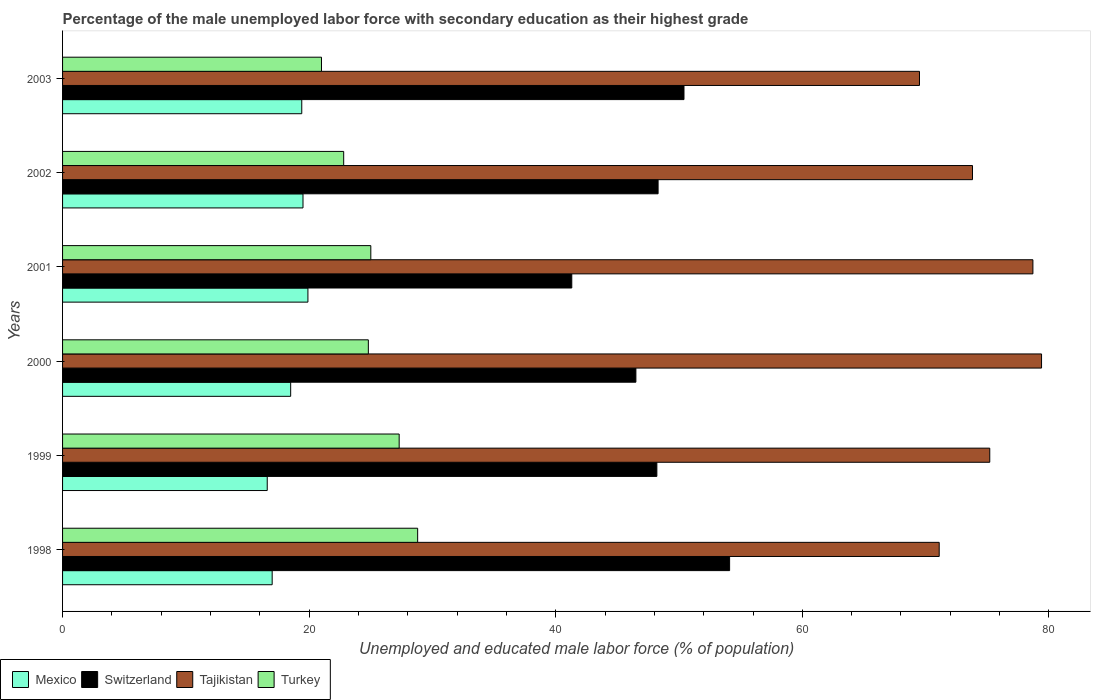How many different coloured bars are there?
Give a very brief answer. 4. How many groups of bars are there?
Your response must be concise. 6. Are the number of bars per tick equal to the number of legend labels?
Your answer should be compact. Yes. How many bars are there on the 2nd tick from the top?
Ensure brevity in your answer.  4. In how many cases, is the number of bars for a given year not equal to the number of legend labels?
Provide a short and direct response. 0. What is the percentage of the unemployed male labor force with secondary education in Turkey in 2002?
Ensure brevity in your answer.  22.8. Across all years, what is the maximum percentage of the unemployed male labor force with secondary education in Turkey?
Your answer should be compact. 28.8. In which year was the percentage of the unemployed male labor force with secondary education in Switzerland maximum?
Offer a terse response. 1998. In which year was the percentage of the unemployed male labor force with secondary education in Tajikistan minimum?
Give a very brief answer. 2003. What is the total percentage of the unemployed male labor force with secondary education in Switzerland in the graph?
Provide a succinct answer. 288.8. What is the difference between the percentage of the unemployed male labor force with secondary education in Mexico in 2001 and that in 2002?
Give a very brief answer. 0.4. What is the difference between the percentage of the unemployed male labor force with secondary education in Tajikistan in 2001 and the percentage of the unemployed male labor force with secondary education in Turkey in 2002?
Your answer should be compact. 55.9. What is the average percentage of the unemployed male labor force with secondary education in Switzerland per year?
Your answer should be compact. 48.13. In the year 2002, what is the difference between the percentage of the unemployed male labor force with secondary education in Turkey and percentage of the unemployed male labor force with secondary education in Tajikistan?
Provide a succinct answer. -51. What is the ratio of the percentage of the unemployed male labor force with secondary education in Switzerland in 1999 to that in 2001?
Keep it short and to the point. 1.17. Is the percentage of the unemployed male labor force with secondary education in Mexico in 1998 less than that in 2003?
Your answer should be very brief. Yes. Is the difference between the percentage of the unemployed male labor force with secondary education in Turkey in 1999 and 2003 greater than the difference between the percentage of the unemployed male labor force with secondary education in Tajikistan in 1999 and 2003?
Your answer should be compact. Yes. What is the difference between the highest and the second highest percentage of the unemployed male labor force with secondary education in Switzerland?
Your answer should be very brief. 3.7. What is the difference between the highest and the lowest percentage of the unemployed male labor force with secondary education in Switzerland?
Offer a terse response. 12.8. What does the 2nd bar from the top in 2003 represents?
Offer a very short reply. Tajikistan. Are the values on the major ticks of X-axis written in scientific E-notation?
Make the answer very short. No. How many legend labels are there?
Your answer should be very brief. 4. What is the title of the graph?
Ensure brevity in your answer.  Percentage of the male unemployed labor force with secondary education as their highest grade. What is the label or title of the X-axis?
Keep it short and to the point. Unemployed and educated male labor force (% of population). What is the label or title of the Y-axis?
Keep it short and to the point. Years. What is the Unemployed and educated male labor force (% of population) in Mexico in 1998?
Provide a succinct answer. 17. What is the Unemployed and educated male labor force (% of population) of Switzerland in 1998?
Give a very brief answer. 54.1. What is the Unemployed and educated male labor force (% of population) of Tajikistan in 1998?
Offer a very short reply. 71.1. What is the Unemployed and educated male labor force (% of population) in Turkey in 1998?
Your answer should be very brief. 28.8. What is the Unemployed and educated male labor force (% of population) of Mexico in 1999?
Give a very brief answer. 16.6. What is the Unemployed and educated male labor force (% of population) in Switzerland in 1999?
Offer a terse response. 48.2. What is the Unemployed and educated male labor force (% of population) in Tajikistan in 1999?
Offer a very short reply. 75.2. What is the Unemployed and educated male labor force (% of population) of Turkey in 1999?
Offer a terse response. 27.3. What is the Unemployed and educated male labor force (% of population) of Mexico in 2000?
Offer a terse response. 18.5. What is the Unemployed and educated male labor force (% of population) of Switzerland in 2000?
Provide a short and direct response. 46.5. What is the Unemployed and educated male labor force (% of population) in Tajikistan in 2000?
Offer a very short reply. 79.4. What is the Unemployed and educated male labor force (% of population) of Turkey in 2000?
Offer a very short reply. 24.8. What is the Unemployed and educated male labor force (% of population) of Mexico in 2001?
Provide a short and direct response. 19.9. What is the Unemployed and educated male labor force (% of population) in Switzerland in 2001?
Your answer should be compact. 41.3. What is the Unemployed and educated male labor force (% of population) in Tajikistan in 2001?
Your answer should be very brief. 78.7. What is the Unemployed and educated male labor force (% of population) in Turkey in 2001?
Ensure brevity in your answer.  25. What is the Unemployed and educated male labor force (% of population) in Switzerland in 2002?
Your answer should be compact. 48.3. What is the Unemployed and educated male labor force (% of population) of Tajikistan in 2002?
Your answer should be compact. 73.8. What is the Unemployed and educated male labor force (% of population) in Turkey in 2002?
Make the answer very short. 22.8. What is the Unemployed and educated male labor force (% of population) in Mexico in 2003?
Provide a short and direct response. 19.4. What is the Unemployed and educated male labor force (% of population) of Switzerland in 2003?
Your answer should be very brief. 50.4. What is the Unemployed and educated male labor force (% of population) in Tajikistan in 2003?
Your response must be concise. 69.5. What is the Unemployed and educated male labor force (% of population) of Turkey in 2003?
Provide a short and direct response. 21. Across all years, what is the maximum Unemployed and educated male labor force (% of population) in Mexico?
Give a very brief answer. 19.9. Across all years, what is the maximum Unemployed and educated male labor force (% of population) of Switzerland?
Your answer should be very brief. 54.1. Across all years, what is the maximum Unemployed and educated male labor force (% of population) in Tajikistan?
Provide a short and direct response. 79.4. Across all years, what is the maximum Unemployed and educated male labor force (% of population) of Turkey?
Offer a terse response. 28.8. Across all years, what is the minimum Unemployed and educated male labor force (% of population) of Mexico?
Give a very brief answer. 16.6. Across all years, what is the minimum Unemployed and educated male labor force (% of population) of Switzerland?
Provide a succinct answer. 41.3. Across all years, what is the minimum Unemployed and educated male labor force (% of population) of Tajikistan?
Give a very brief answer. 69.5. Across all years, what is the minimum Unemployed and educated male labor force (% of population) in Turkey?
Your answer should be compact. 21. What is the total Unemployed and educated male labor force (% of population) in Mexico in the graph?
Offer a terse response. 110.9. What is the total Unemployed and educated male labor force (% of population) in Switzerland in the graph?
Your answer should be compact. 288.8. What is the total Unemployed and educated male labor force (% of population) in Tajikistan in the graph?
Provide a short and direct response. 447.7. What is the total Unemployed and educated male labor force (% of population) in Turkey in the graph?
Provide a short and direct response. 149.7. What is the difference between the Unemployed and educated male labor force (% of population) in Turkey in 1998 and that in 1999?
Provide a short and direct response. 1.5. What is the difference between the Unemployed and educated male labor force (% of population) in Mexico in 1998 and that in 2000?
Provide a short and direct response. -1.5. What is the difference between the Unemployed and educated male labor force (% of population) of Switzerland in 1998 and that in 2000?
Provide a succinct answer. 7.6. What is the difference between the Unemployed and educated male labor force (% of population) in Turkey in 1998 and that in 2000?
Provide a short and direct response. 4. What is the difference between the Unemployed and educated male labor force (% of population) in Tajikistan in 1998 and that in 2001?
Keep it short and to the point. -7.6. What is the difference between the Unemployed and educated male labor force (% of population) in Turkey in 1998 and that in 2001?
Offer a terse response. 3.8. What is the difference between the Unemployed and educated male labor force (% of population) of Mexico in 1998 and that in 2002?
Provide a succinct answer. -2.5. What is the difference between the Unemployed and educated male labor force (% of population) of Switzerland in 1998 and that in 2002?
Your answer should be compact. 5.8. What is the difference between the Unemployed and educated male labor force (% of population) of Tajikistan in 1998 and that in 2002?
Keep it short and to the point. -2.7. What is the difference between the Unemployed and educated male labor force (% of population) of Turkey in 1998 and that in 2003?
Give a very brief answer. 7.8. What is the difference between the Unemployed and educated male labor force (% of population) of Mexico in 1999 and that in 2000?
Offer a terse response. -1.9. What is the difference between the Unemployed and educated male labor force (% of population) of Tajikistan in 1999 and that in 2000?
Keep it short and to the point. -4.2. What is the difference between the Unemployed and educated male labor force (% of population) in Tajikistan in 1999 and that in 2001?
Make the answer very short. -3.5. What is the difference between the Unemployed and educated male labor force (% of population) in Turkey in 1999 and that in 2001?
Keep it short and to the point. 2.3. What is the difference between the Unemployed and educated male labor force (% of population) of Switzerland in 1999 and that in 2002?
Your response must be concise. -0.1. What is the difference between the Unemployed and educated male labor force (% of population) of Tajikistan in 1999 and that in 2002?
Provide a short and direct response. 1.4. What is the difference between the Unemployed and educated male labor force (% of population) of Mexico in 1999 and that in 2003?
Offer a terse response. -2.8. What is the difference between the Unemployed and educated male labor force (% of population) in Mexico in 2000 and that in 2001?
Give a very brief answer. -1.4. What is the difference between the Unemployed and educated male labor force (% of population) of Tajikistan in 2000 and that in 2001?
Give a very brief answer. 0.7. What is the difference between the Unemployed and educated male labor force (% of population) of Turkey in 2000 and that in 2001?
Keep it short and to the point. -0.2. What is the difference between the Unemployed and educated male labor force (% of population) in Switzerland in 2000 and that in 2002?
Your answer should be compact. -1.8. What is the difference between the Unemployed and educated male labor force (% of population) in Tajikistan in 2000 and that in 2002?
Your answer should be compact. 5.6. What is the difference between the Unemployed and educated male labor force (% of population) of Turkey in 2000 and that in 2002?
Give a very brief answer. 2. What is the difference between the Unemployed and educated male labor force (% of population) in Mexico in 2000 and that in 2003?
Your answer should be very brief. -0.9. What is the difference between the Unemployed and educated male labor force (% of population) in Switzerland in 2000 and that in 2003?
Provide a short and direct response. -3.9. What is the difference between the Unemployed and educated male labor force (% of population) in Tajikistan in 2000 and that in 2003?
Make the answer very short. 9.9. What is the difference between the Unemployed and educated male labor force (% of population) of Switzerland in 2001 and that in 2002?
Give a very brief answer. -7. What is the difference between the Unemployed and educated male labor force (% of population) of Turkey in 2001 and that in 2002?
Provide a succinct answer. 2.2. What is the difference between the Unemployed and educated male labor force (% of population) of Switzerland in 2001 and that in 2003?
Your answer should be compact. -9.1. What is the difference between the Unemployed and educated male labor force (% of population) of Tajikistan in 2001 and that in 2003?
Provide a succinct answer. 9.2. What is the difference between the Unemployed and educated male labor force (% of population) of Turkey in 2001 and that in 2003?
Provide a short and direct response. 4. What is the difference between the Unemployed and educated male labor force (% of population) of Mexico in 2002 and that in 2003?
Keep it short and to the point. 0.1. What is the difference between the Unemployed and educated male labor force (% of population) in Switzerland in 2002 and that in 2003?
Keep it short and to the point. -2.1. What is the difference between the Unemployed and educated male labor force (% of population) in Turkey in 2002 and that in 2003?
Provide a short and direct response. 1.8. What is the difference between the Unemployed and educated male labor force (% of population) of Mexico in 1998 and the Unemployed and educated male labor force (% of population) of Switzerland in 1999?
Your response must be concise. -31.2. What is the difference between the Unemployed and educated male labor force (% of population) in Mexico in 1998 and the Unemployed and educated male labor force (% of population) in Tajikistan in 1999?
Your response must be concise. -58.2. What is the difference between the Unemployed and educated male labor force (% of population) of Switzerland in 1998 and the Unemployed and educated male labor force (% of population) of Tajikistan in 1999?
Provide a short and direct response. -21.1. What is the difference between the Unemployed and educated male labor force (% of population) of Switzerland in 1998 and the Unemployed and educated male labor force (% of population) of Turkey in 1999?
Offer a very short reply. 26.8. What is the difference between the Unemployed and educated male labor force (% of population) in Tajikistan in 1998 and the Unemployed and educated male labor force (% of population) in Turkey in 1999?
Offer a very short reply. 43.8. What is the difference between the Unemployed and educated male labor force (% of population) of Mexico in 1998 and the Unemployed and educated male labor force (% of population) of Switzerland in 2000?
Ensure brevity in your answer.  -29.5. What is the difference between the Unemployed and educated male labor force (% of population) of Mexico in 1998 and the Unemployed and educated male labor force (% of population) of Tajikistan in 2000?
Keep it short and to the point. -62.4. What is the difference between the Unemployed and educated male labor force (% of population) of Mexico in 1998 and the Unemployed and educated male labor force (% of population) of Turkey in 2000?
Offer a very short reply. -7.8. What is the difference between the Unemployed and educated male labor force (% of population) of Switzerland in 1998 and the Unemployed and educated male labor force (% of population) of Tajikistan in 2000?
Provide a succinct answer. -25.3. What is the difference between the Unemployed and educated male labor force (% of population) of Switzerland in 1998 and the Unemployed and educated male labor force (% of population) of Turkey in 2000?
Your answer should be very brief. 29.3. What is the difference between the Unemployed and educated male labor force (% of population) in Tajikistan in 1998 and the Unemployed and educated male labor force (% of population) in Turkey in 2000?
Provide a succinct answer. 46.3. What is the difference between the Unemployed and educated male labor force (% of population) in Mexico in 1998 and the Unemployed and educated male labor force (% of population) in Switzerland in 2001?
Give a very brief answer. -24.3. What is the difference between the Unemployed and educated male labor force (% of population) in Mexico in 1998 and the Unemployed and educated male labor force (% of population) in Tajikistan in 2001?
Offer a terse response. -61.7. What is the difference between the Unemployed and educated male labor force (% of population) of Switzerland in 1998 and the Unemployed and educated male labor force (% of population) of Tajikistan in 2001?
Provide a succinct answer. -24.6. What is the difference between the Unemployed and educated male labor force (% of population) in Switzerland in 1998 and the Unemployed and educated male labor force (% of population) in Turkey in 2001?
Offer a terse response. 29.1. What is the difference between the Unemployed and educated male labor force (% of population) of Tajikistan in 1998 and the Unemployed and educated male labor force (% of population) of Turkey in 2001?
Keep it short and to the point. 46.1. What is the difference between the Unemployed and educated male labor force (% of population) of Mexico in 1998 and the Unemployed and educated male labor force (% of population) of Switzerland in 2002?
Keep it short and to the point. -31.3. What is the difference between the Unemployed and educated male labor force (% of population) in Mexico in 1998 and the Unemployed and educated male labor force (% of population) in Tajikistan in 2002?
Provide a short and direct response. -56.8. What is the difference between the Unemployed and educated male labor force (% of population) in Switzerland in 1998 and the Unemployed and educated male labor force (% of population) in Tajikistan in 2002?
Your answer should be compact. -19.7. What is the difference between the Unemployed and educated male labor force (% of population) in Switzerland in 1998 and the Unemployed and educated male labor force (% of population) in Turkey in 2002?
Offer a terse response. 31.3. What is the difference between the Unemployed and educated male labor force (% of population) of Tajikistan in 1998 and the Unemployed and educated male labor force (% of population) of Turkey in 2002?
Provide a short and direct response. 48.3. What is the difference between the Unemployed and educated male labor force (% of population) in Mexico in 1998 and the Unemployed and educated male labor force (% of population) in Switzerland in 2003?
Give a very brief answer. -33.4. What is the difference between the Unemployed and educated male labor force (% of population) in Mexico in 1998 and the Unemployed and educated male labor force (% of population) in Tajikistan in 2003?
Provide a succinct answer. -52.5. What is the difference between the Unemployed and educated male labor force (% of population) of Switzerland in 1998 and the Unemployed and educated male labor force (% of population) of Tajikistan in 2003?
Give a very brief answer. -15.4. What is the difference between the Unemployed and educated male labor force (% of population) in Switzerland in 1998 and the Unemployed and educated male labor force (% of population) in Turkey in 2003?
Keep it short and to the point. 33.1. What is the difference between the Unemployed and educated male labor force (% of population) in Tajikistan in 1998 and the Unemployed and educated male labor force (% of population) in Turkey in 2003?
Your response must be concise. 50.1. What is the difference between the Unemployed and educated male labor force (% of population) of Mexico in 1999 and the Unemployed and educated male labor force (% of population) of Switzerland in 2000?
Your answer should be very brief. -29.9. What is the difference between the Unemployed and educated male labor force (% of population) of Mexico in 1999 and the Unemployed and educated male labor force (% of population) of Tajikistan in 2000?
Your answer should be very brief. -62.8. What is the difference between the Unemployed and educated male labor force (% of population) of Switzerland in 1999 and the Unemployed and educated male labor force (% of population) of Tajikistan in 2000?
Give a very brief answer. -31.2. What is the difference between the Unemployed and educated male labor force (% of population) in Switzerland in 1999 and the Unemployed and educated male labor force (% of population) in Turkey in 2000?
Your answer should be compact. 23.4. What is the difference between the Unemployed and educated male labor force (% of population) of Tajikistan in 1999 and the Unemployed and educated male labor force (% of population) of Turkey in 2000?
Offer a terse response. 50.4. What is the difference between the Unemployed and educated male labor force (% of population) of Mexico in 1999 and the Unemployed and educated male labor force (% of population) of Switzerland in 2001?
Provide a succinct answer. -24.7. What is the difference between the Unemployed and educated male labor force (% of population) of Mexico in 1999 and the Unemployed and educated male labor force (% of population) of Tajikistan in 2001?
Offer a very short reply. -62.1. What is the difference between the Unemployed and educated male labor force (% of population) of Mexico in 1999 and the Unemployed and educated male labor force (% of population) of Turkey in 2001?
Keep it short and to the point. -8.4. What is the difference between the Unemployed and educated male labor force (% of population) of Switzerland in 1999 and the Unemployed and educated male labor force (% of population) of Tajikistan in 2001?
Offer a very short reply. -30.5. What is the difference between the Unemployed and educated male labor force (% of population) of Switzerland in 1999 and the Unemployed and educated male labor force (% of population) of Turkey in 2001?
Your response must be concise. 23.2. What is the difference between the Unemployed and educated male labor force (% of population) in Tajikistan in 1999 and the Unemployed and educated male labor force (% of population) in Turkey in 2001?
Make the answer very short. 50.2. What is the difference between the Unemployed and educated male labor force (% of population) in Mexico in 1999 and the Unemployed and educated male labor force (% of population) in Switzerland in 2002?
Give a very brief answer. -31.7. What is the difference between the Unemployed and educated male labor force (% of population) of Mexico in 1999 and the Unemployed and educated male labor force (% of population) of Tajikistan in 2002?
Provide a succinct answer. -57.2. What is the difference between the Unemployed and educated male labor force (% of population) in Mexico in 1999 and the Unemployed and educated male labor force (% of population) in Turkey in 2002?
Provide a succinct answer. -6.2. What is the difference between the Unemployed and educated male labor force (% of population) of Switzerland in 1999 and the Unemployed and educated male labor force (% of population) of Tajikistan in 2002?
Give a very brief answer. -25.6. What is the difference between the Unemployed and educated male labor force (% of population) of Switzerland in 1999 and the Unemployed and educated male labor force (% of population) of Turkey in 2002?
Keep it short and to the point. 25.4. What is the difference between the Unemployed and educated male labor force (% of population) of Tajikistan in 1999 and the Unemployed and educated male labor force (% of population) of Turkey in 2002?
Offer a terse response. 52.4. What is the difference between the Unemployed and educated male labor force (% of population) in Mexico in 1999 and the Unemployed and educated male labor force (% of population) in Switzerland in 2003?
Your answer should be very brief. -33.8. What is the difference between the Unemployed and educated male labor force (% of population) in Mexico in 1999 and the Unemployed and educated male labor force (% of population) in Tajikistan in 2003?
Ensure brevity in your answer.  -52.9. What is the difference between the Unemployed and educated male labor force (% of population) in Mexico in 1999 and the Unemployed and educated male labor force (% of population) in Turkey in 2003?
Provide a succinct answer. -4.4. What is the difference between the Unemployed and educated male labor force (% of population) in Switzerland in 1999 and the Unemployed and educated male labor force (% of population) in Tajikistan in 2003?
Your answer should be very brief. -21.3. What is the difference between the Unemployed and educated male labor force (% of population) in Switzerland in 1999 and the Unemployed and educated male labor force (% of population) in Turkey in 2003?
Offer a very short reply. 27.2. What is the difference between the Unemployed and educated male labor force (% of population) in Tajikistan in 1999 and the Unemployed and educated male labor force (% of population) in Turkey in 2003?
Ensure brevity in your answer.  54.2. What is the difference between the Unemployed and educated male labor force (% of population) of Mexico in 2000 and the Unemployed and educated male labor force (% of population) of Switzerland in 2001?
Your answer should be very brief. -22.8. What is the difference between the Unemployed and educated male labor force (% of population) of Mexico in 2000 and the Unemployed and educated male labor force (% of population) of Tajikistan in 2001?
Make the answer very short. -60.2. What is the difference between the Unemployed and educated male labor force (% of population) of Switzerland in 2000 and the Unemployed and educated male labor force (% of population) of Tajikistan in 2001?
Provide a succinct answer. -32.2. What is the difference between the Unemployed and educated male labor force (% of population) of Switzerland in 2000 and the Unemployed and educated male labor force (% of population) of Turkey in 2001?
Your answer should be compact. 21.5. What is the difference between the Unemployed and educated male labor force (% of population) of Tajikistan in 2000 and the Unemployed and educated male labor force (% of population) of Turkey in 2001?
Your response must be concise. 54.4. What is the difference between the Unemployed and educated male labor force (% of population) of Mexico in 2000 and the Unemployed and educated male labor force (% of population) of Switzerland in 2002?
Make the answer very short. -29.8. What is the difference between the Unemployed and educated male labor force (% of population) in Mexico in 2000 and the Unemployed and educated male labor force (% of population) in Tajikistan in 2002?
Ensure brevity in your answer.  -55.3. What is the difference between the Unemployed and educated male labor force (% of population) of Switzerland in 2000 and the Unemployed and educated male labor force (% of population) of Tajikistan in 2002?
Provide a succinct answer. -27.3. What is the difference between the Unemployed and educated male labor force (% of population) of Switzerland in 2000 and the Unemployed and educated male labor force (% of population) of Turkey in 2002?
Keep it short and to the point. 23.7. What is the difference between the Unemployed and educated male labor force (% of population) of Tajikistan in 2000 and the Unemployed and educated male labor force (% of population) of Turkey in 2002?
Your answer should be very brief. 56.6. What is the difference between the Unemployed and educated male labor force (% of population) of Mexico in 2000 and the Unemployed and educated male labor force (% of population) of Switzerland in 2003?
Make the answer very short. -31.9. What is the difference between the Unemployed and educated male labor force (% of population) of Mexico in 2000 and the Unemployed and educated male labor force (% of population) of Tajikistan in 2003?
Provide a short and direct response. -51. What is the difference between the Unemployed and educated male labor force (% of population) of Tajikistan in 2000 and the Unemployed and educated male labor force (% of population) of Turkey in 2003?
Provide a succinct answer. 58.4. What is the difference between the Unemployed and educated male labor force (% of population) in Mexico in 2001 and the Unemployed and educated male labor force (% of population) in Switzerland in 2002?
Ensure brevity in your answer.  -28.4. What is the difference between the Unemployed and educated male labor force (% of population) in Mexico in 2001 and the Unemployed and educated male labor force (% of population) in Tajikistan in 2002?
Give a very brief answer. -53.9. What is the difference between the Unemployed and educated male labor force (% of population) of Mexico in 2001 and the Unemployed and educated male labor force (% of population) of Turkey in 2002?
Keep it short and to the point. -2.9. What is the difference between the Unemployed and educated male labor force (% of population) in Switzerland in 2001 and the Unemployed and educated male labor force (% of population) in Tajikistan in 2002?
Your answer should be very brief. -32.5. What is the difference between the Unemployed and educated male labor force (% of population) of Switzerland in 2001 and the Unemployed and educated male labor force (% of population) of Turkey in 2002?
Ensure brevity in your answer.  18.5. What is the difference between the Unemployed and educated male labor force (% of population) in Tajikistan in 2001 and the Unemployed and educated male labor force (% of population) in Turkey in 2002?
Your response must be concise. 55.9. What is the difference between the Unemployed and educated male labor force (% of population) in Mexico in 2001 and the Unemployed and educated male labor force (% of population) in Switzerland in 2003?
Your answer should be very brief. -30.5. What is the difference between the Unemployed and educated male labor force (% of population) of Mexico in 2001 and the Unemployed and educated male labor force (% of population) of Tajikistan in 2003?
Your response must be concise. -49.6. What is the difference between the Unemployed and educated male labor force (% of population) of Mexico in 2001 and the Unemployed and educated male labor force (% of population) of Turkey in 2003?
Your answer should be very brief. -1.1. What is the difference between the Unemployed and educated male labor force (% of population) in Switzerland in 2001 and the Unemployed and educated male labor force (% of population) in Tajikistan in 2003?
Offer a terse response. -28.2. What is the difference between the Unemployed and educated male labor force (% of population) of Switzerland in 2001 and the Unemployed and educated male labor force (% of population) of Turkey in 2003?
Offer a terse response. 20.3. What is the difference between the Unemployed and educated male labor force (% of population) in Tajikistan in 2001 and the Unemployed and educated male labor force (% of population) in Turkey in 2003?
Give a very brief answer. 57.7. What is the difference between the Unemployed and educated male labor force (% of population) in Mexico in 2002 and the Unemployed and educated male labor force (% of population) in Switzerland in 2003?
Provide a short and direct response. -30.9. What is the difference between the Unemployed and educated male labor force (% of population) of Mexico in 2002 and the Unemployed and educated male labor force (% of population) of Tajikistan in 2003?
Offer a very short reply. -50. What is the difference between the Unemployed and educated male labor force (% of population) in Switzerland in 2002 and the Unemployed and educated male labor force (% of population) in Tajikistan in 2003?
Keep it short and to the point. -21.2. What is the difference between the Unemployed and educated male labor force (% of population) of Switzerland in 2002 and the Unemployed and educated male labor force (% of population) of Turkey in 2003?
Offer a very short reply. 27.3. What is the difference between the Unemployed and educated male labor force (% of population) in Tajikistan in 2002 and the Unemployed and educated male labor force (% of population) in Turkey in 2003?
Offer a terse response. 52.8. What is the average Unemployed and educated male labor force (% of population) in Mexico per year?
Make the answer very short. 18.48. What is the average Unemployed and educated male labor force (% of population) in Switzerland per year?
Offer a very short reply. 48.13. What is the average Unemployed and educated male labor force (% of population) in Tajikistan per year?
Provide a short and direct response. 74.62. What is the average Unemployed and educated male labor force (% of population) of Turkey per year?
Your answer should be very brief. 24.95. In the year 1998, what is the difference between the Unemployed and educated male labor force (% of population) of Mexico and Unemployed and educated male labor force (% of population) of Switzerland?
Keep it short and to the point. -37.1. In the year 1998, what is the difference between the Unemployed and educated male labor force (% of population) in Mexico and Unemployed and educated male labor force (% of population) in Tajikistan?
Offer a very short reply. -54.1. In the year 1998, what is the difference between the Unemployed and educated male labor force (% of population) in Switzerland and Unemployed and educated male labor force (% of population) in Tajikistan?
Your response must be concise. -17. In the year 1998, what is the difference between the Unemployed and educated male labor force (% of population) in Switzerland and Unemployed and educated male labor force (% of population) in Turkey?
Your answer should be very brief. 25.3. In the year 1998, what is the difference between the Unemployed and educated male labor force (% of population) in Tajikistan and Unemployed and educated male labor force (% of population) in Turkey?
Your answer should be very brief. 42.3. In the year 1999, what is the difference between the Unemployed and educated male labor force (% of population) in Mexico and Unemployed and educated male labor force (% of population) in Switzerland?
Keep it short and to the point. -31.6. In the year 1999, what is the difference between the Unemployed and educated male labor force (% of population) in Mexico and Unemployed and educated male labor force (% of population) in Tajikistan?
Provide a short and direct response. -58.6. In the year 1999, what is the difference between the Unemployed and educated male labor force (% of population) of Mexico and Unemployed and educated male labor force (% of population) of Turkey?
Provide a succinct answer. -10.7. In the year 1999, what is the difference between the Unemployed and educated male labor force (% of population) of Switzerland and Unemployed and educated male labor force (% of population) of Turkey?
Offer a terse response. 20.9. In the year 1999, what is the difference between the Unemployed and educated male labor force (% of population) of Tajikistan and Unemployed and educated male labor force (% of population) of Turkey?
Make the answer very short. 47.9. In the year 2000, what is the difference between the Unemployed and educated male labor force (% of population) of Mexico and Unemployed and educated male labor force (% of population) of Switzerland?
Offer a very short reply. -28. In the year 2000, what is the difference between the Unemployed and educated male labor force (% of population) of Mexico and Unemployed and educated male labor force (% of population) of Tajikistan?
Give a very brief answer. -60.9. In the year 2000, what is the difference between the Unemployed and educated male labor force (% of population) of Switzerland and Unemployed and educated male labor force (% of population) of Tajikistan?
Give a very brief answer. -32.9. In the year 2000, what is the difference between the Unemployed and educated male labor force (% of population) of Switzerland and Unemployed and educated male labor force (% of population) of Turkey?
Provide a succinct answer. 21.7. In the year 2000, what is the difference between the Unemployed and educated male labor force (% of population) in Tajikistan and Unemployed and educated male labor force (% of population) in Turkey?
Make the answer very short. 54.6. In the year 2001, what is the difference between the Unemployed and educated male labor force (% of population) in Mexico and Unemployed and educated male labor force (% of population) in Switzerland?
Make the answer very short. -21.4. In the year 2001, what is the difference between the Unemployed and educated male labor force (% of population) of Mexico and Unemployed and educated male labor force (% of population) of Tajikistan?
Give a very brief answer. -58.8. In the year 2001, what is the difference between the Unemployed and educated male labor force (% of population) in Switzerland and Unemployed and educated male labor force (% of population) in Tajikistan?
Make the answer very short. -37.4. In the year 2001, what is the difference between the Unemployed and educated male labor force (% of population) of Tajikistan and Unemployed and educated male labor force (% of population) of Turkey?
Your answer should be very brief. 53.7. In the year 2002, what is the difference between the Unemployed and educated male labor force (% of population) in Mexico and Unemployed and educated male labor force (% of population) in Switzerland?
Offer a very short reply. -28.8. In the year 2002, what is the difference between the Unemployed and educated male labor force (% of population) in Mexico and Unemployed and educated male labor force (% of population) in Tajikistan?
Provide a succinct answer. -54.3. In the year 2002, what is the difference between the Unemployed and educated male labor force (% of population) of Mexico and Unemployed and educated male labor force (% of population) of Turkey?
Provide a short and direct response. -3.3. In the year 2002, what is the difference between the Unemployed and educated male labor force (% of population) in Switzerland and Unemployed and educated male labor force (% of population) in Tajikistan?
Your response must be concise. -25.5. In the year 2002, what is the difference between the Unemployed and educated male labor force (% of population) in Switzerland and Unemployed and educated male labor force (% of population) in Turkey?
Ensure brevity in your answer.  25.5. In the year 2002, what is the difference between the Unemployed and educated male labor force (% of population) in Tajikistan and Unemployed and educated male labor force (% of population) in Turkey?
Your response must be concise. 51. In the year 2003, what is the difference between the Unemployed and educated male labor force (% of population) in Mexico and Unemployed and educated male labor force (% of population) in Switzerland?
Keep it short and to the point. -31. In the year 2003, what is the difference between the Unemployed and educated male labor force (% of population) in Mexico and Unemployed and educated male labor force (% of population) in Tajikistan?
Ensure brevity in your answer.  -50.1. In the year 2003, what is the difference between the Unemployed and educated male labor force (% of population) in Mexico and Unemployed and educated male labor force (% of population) in Turkey?
Keep it short and to the point. -1.6. In the year 2003, what is the difference between the Unemployed and educated male labor force (% of population) in Switzerland and Unemployed and educated male labor force (% of population) in Tajikistan?
Offer a terse response. -19.1. In the year 2003, what is the difference between the Unemployed and educated male labor force (% of population) in Switzerland and Unemployed and educated male labor force (% of population) in Turkey?
Provide a succinct answer. 29.4. In the year 2003, what is the difference between the Unemployed and educated male labor force (% of population) of Tajikistan and Unemployed and educated male labor force (% of population) of Turkey?
Your response must be concise. 48.5. What is the ratio of the Unemployed and educated male labor force (% of population) of Mexico in 1998 to that in 1999?
Make the answer very short. 1.02. What is the ratio of the Unemployed and educated male labor force (% of population) of Switzerland in 1998 to that in 1999?
Offer a terse response. 1.12. What is the ratio of the Unemployed and educated male labor force (% of population) in Tajikistan in 1998 to that in 1999?
Make the answer very short. 0.95. What is the ratio of the Unemployed and educated male labor force (% of population) of Turkey in 1998 to that in 1999?
Your response must be concise. 1.05. What is the ratio of the Unemployed and educated male labor force (% of population) in Mexico in 1998 to that in 2000?
Provide a short and direct response. 0.92. What is the ratio of the Unemployed and educated male labor force (% of population) of Switzerland in 1998 to that in 2000?
Offer a terse response. 1.16. What is the ratio of the Unemployed and educated male labor force (% of population) in Tajikistan in 1998 to that in 2000?
Give a very brief answer. 0.9. What is the ratio of the Unemployed and educated male labor force (% of population) of Turkey in 1998 to that in 2000?
Ensure brevity in your answer.  1.16. What is the ratio of the Unemployed and educated male labor force (% of population) in Mexico in 1998 to that in 2001?
Ensure brevity in your answer.  0.85. What is the ratio of the Unemployed and educated male labor force (% of population) in Switzerland in 1998 to that in 2001?
Offer a terse response. 1.31. What is the ratio of the Unemployed and educated male labor force (% of population) in Tajikistan in 1998 to that in 2001?
Keep it short and to the point. 0.9. What is the ratio of the Unemployed and educated male labor force (% of population) in Turkey in 1998 to that in 2001?
Ensure brevity in your answer.  1.15. What is the ratio of the Unemployed and educated male labor force (% of population) of Mexico in 1998 to that in 2002?
Offer a terse response. 0.87. What is the ratio of the Unemployed and educated male labor force (% of population) of Switzerland in 1998 to that in 2002?
Your answer should be compact. 1.12. What is the ratio of the Unemployed and educated male labor force (% of population) of Tajikistan in 1998 to that in 2002?
Offer a terse response. 0.96. What is the ratio of the Unemployed and educated male labor force (% of population) in Turkey in 1998 to that in 2002?
Make the answer very short. 1.26. What is the ratio of the Unemployed and educated male labor force (% of population) of Mexico in 1998 to that in 2003?
Offer a very short reply. 0.88. What is the ratio of the Unemployed and educated male labor force (% of population) of Switzerland in 1998 to that in 2003?
Offer a terse response. 1.07. What is the ratio of the Unemployed and educated male labor force (% of population) of Turkey in 1998 to that in 2003?
Give a very brief answer. 1.37. What is the ratio of the Unemployed and educated male labor force (% of population) of Mexico in 1999 to that in 2000?
Ensure brevity in your answer.  0.9. What is the ratio of the Unemployed and educated male labor force (% of population) in Switzerland in 1999 to that in 2000?
Provide a succinct answer. 1.04. What is the ratio of the Unemployed and educated male labor force (% of population) of Tajikistan in 1999 to that in 2000?
Keep it short and to the point. 0.95. What is the ratio of the Unemployed and educated male labor force (% of population) of Turkey in 1999 to that in 2000?
Offer a terse response. 1.1. What is the ratio of the Unemployed and educated male labor force (% of population) in Mexico in 1999 to that in 2001?
Offer a very short reply. 0.83. What is the ratio of the Unemployed and educated male labor force (% of population) in Switzerland in 1999 to that in 2001?
Provide a short and direct response. 1.17. What is the ratio of the Unemployed and educated male labor force (% of population) of Tajikistan in 1999 to that in 2001?
Ensure brevity in your answer.  0.96. What is the ratio of the Unemployed and educated male labor force (% of population) of Turkey in 1999 to that in 2001?
Your answer should be very brief. 1.09. What is the ratio of the Unemployed and educated male labor force (% of population) of Mexico in 1999 to that in 2002?
Your answer should be very brief. 0.85. What is the ratio of the Unemployed and educated male labor force (% of population) of Turkey in 1999 to that in 2002?
Provide a succinct answer. 1.2. What is the ratio of the Unemployed and educated male labor force (% of population) in Mexico in 1999 to that in 2003?
Your answer should be very brief. 0.86. What is the ratio of the Unemployed and educated male labor force (% of population) in Switzerland in 1999 to that in 2003?
Your response must be concise. 0.96. What is the ratio of the Unemployed and educated male labor force (% of population) of Tajikistan in 1999 to that in 2003?
Your answer should be compact. 1.08. What is the ratio of the Unemployed and educated male labor force (% of population) in Mexico in 2000 to that in 2001?
Keep it short and to the point. 0.93. What is the ratio of the Unemployed and educated male labor force (% of population) in Switzerland in 2000 to that in 2001?
Make the answer very short. 1.13. What is the ratio of the Unemployed and educated male labor force (% of population) in Tajikistan in 2000 to that in 2001?
Give a very brief answer. 1.01. What is the ratio of the Unemployed and educated male labor force (% of population) of Mexico in 2000 to that in 2002?
Your response must be concise. 0.95. What is the ratio of the Unemployed and educated male labor force (% of population) of Switzerland in 2000 to that in 2002?
Your answer should be compact. 0.96. What is the ratio of the Unemployed and educated male labor force (% of population) in Tajikistan in 2000 to that in 2002?
Keep it short and to the point. 1.08. What is the ratio of the Unemployed and educated male labor force (% of population) of Turkey in 2000 to that in 2002?
Offer a terse response. 1.09. What is the ratio of the Unemployed and educated male labor force (% of population) in Mexico in 2000 to that in 2003?
Provide a short and direct response. 0.95. What is the ratio of the Unemployed and educated male labor force (% of population) of Switzerland in 2000 to that in 2003?
Your response must be concise. 0.92. What is the ratio of the Unemployed and educated male labor force (% of population) of Tajikistan in 2000 to that in 2003?
Offer a terse response. 1.14. What is the ratio of the Unemployed and educated male labor force (% of population) of Turkey in 2000 to that in 2003?
Offer a very short reply. 1.18. What is the ratio of the Unemployed and educated male labor force (% of population) in Mexico in 2001 to that in 2002?
Your answer should be compact. 1.02. What is the ratio of the Unemployed and educated male labor force (% of population) in Switzerland in 2001 to that in 2002?
Your answer should be compact. 0.86. What is the ratio of the Unemployed and educated male labor force (% of population) of Tajikistan in 2001 to that in 2002?
Provide a short and direct response. 1.07. What is the ratio of the Unemployed and educated male labor force (% of population) of Turkey in 2001 to that in 2002?
Give a very brief answer. 1.1. What is the ratio of the Unemployed and educated male labor force (% of population) of Mexico in 2001 to that in 2003?
Provide a short and direct response. 1.03. What is the ratio of the Unemployed and educated male labor force (% of population) of Switzerland in 2001 to that in 2003?
Offer a terse response. 0.82. What is the ratio of the Unemployed and educated male labor force (% of population) in Tajikistan in 2001 to that in 2003?
Provide a short and direct response. 1.13. What is the ratio of the Unemployed and educated male labor force (% of population) in Turkey in 2001 to that in 2003?
Provide a short and direct response. 1.19. What is the ratio of the Unemployed and educated male labor force (% of population) in Tajikistan in 2002 to that in 2003?
Give a very brief answer. 1.06. What is the ratio of the Unemployed and educated male labor force (% of population) of Turkey in 2002 to that in 2003?
Keep it short and to the point. 1.09. What is the difference between the highest and the second highest Unemployed and educated male labor force (% of population) in Mexico?
Offer a terse response. 0.4. What is the difference between the highest and the second highest Unemployed and educated male labor force (% of population) of Switzerland?
Offer a very short reply. 3.7. What is the difference between the highest and the lowest Unemployed and educated male labor force (% of population) of Switzerland?
Provide a succinct answer. 12.8. 